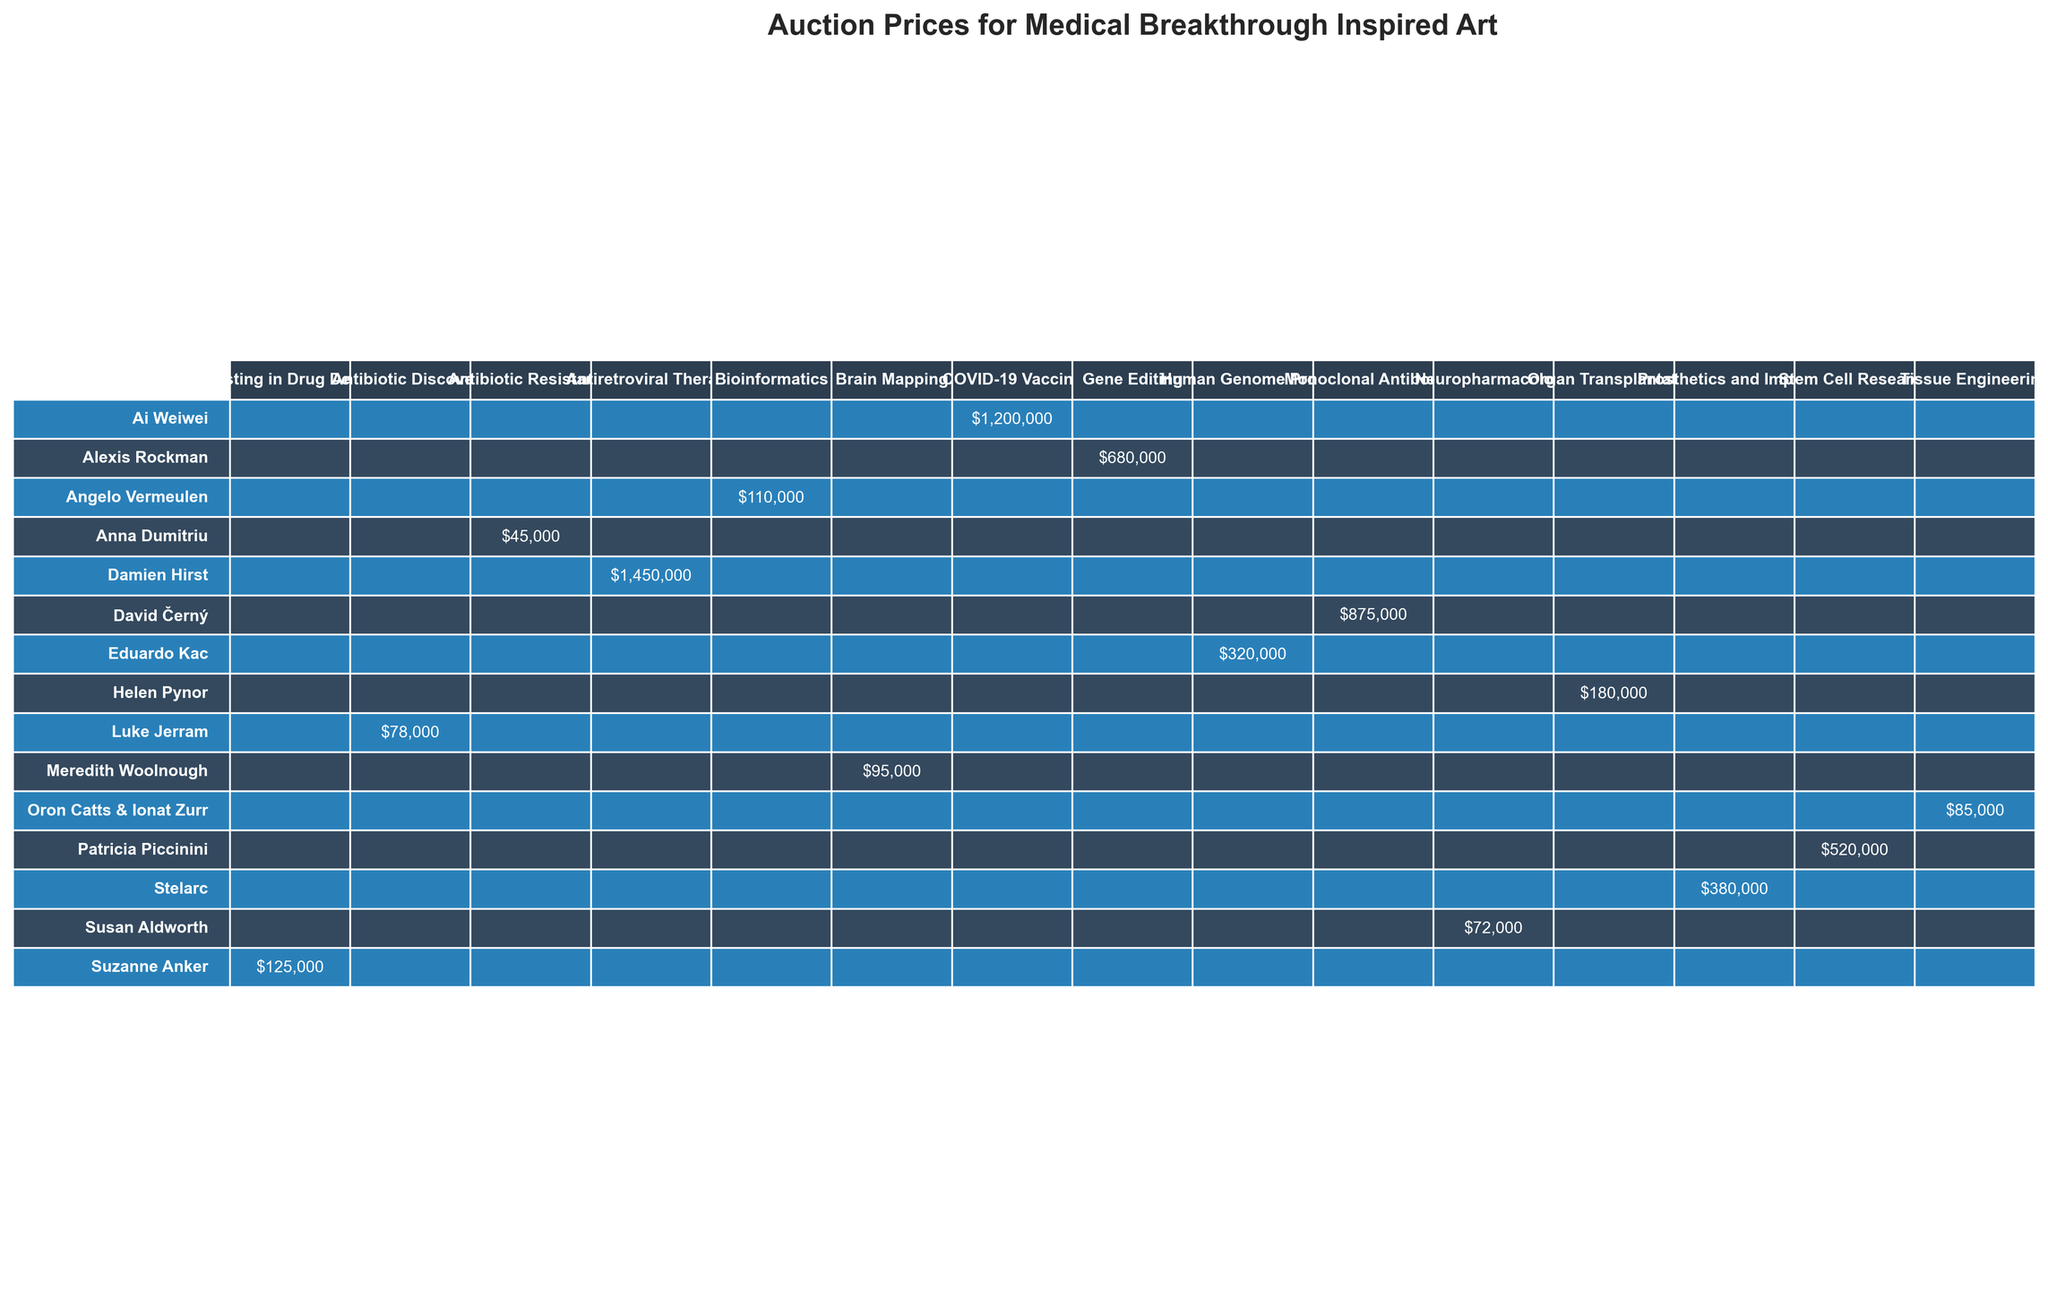What is the highest auction price for an artwork inspired by medical breakthroughs? The table shows that the highest auction price is for "The Cure - Orange" by Damien Hirst, which sold for $1,450,000 at Sotheby's in 2019.
Answer: $1,450,000 Which artwork had the lowest hammer price and what was its price? The lowest hammer price in the table is for "MRSA Quilt" by Anna Dumitriu, which sold for $45,000 through Phillips in 2020.
Answer: $45,000 How many artworks were sold at Christie’s? The table lists three artworks sold at Christie’s: "Antibodies," "The Body is a Big Place," and "Passing Thoughts."
Answer: 3 What is the total hammer price of all artworks sold at Sotheby's? The hammer prices for artworks sold at Sotheby's are $1,450,000 (Damien Hirst), $1,200,000 (Ai Weiwei), and $380,000 (Stelarc). Summing these gives $1,450,000 + $1,200,000 + $380,000 = $3,030,000.
Answer: $3,030,000 Which artist created a piece inspired by Gene Editing, and what was its hammer price? The artwork "CRISPR Landscape" by Alexis Rockman is inspired by Gene Editing and had a hammer price of $680,000.
Answer: Alexis Rockman, $680,000 Is there an artwork that uses living tissue as a medium? Yes, "Victimless Leather" by Oron Catts & Ionat Zurr is a living tissue installation, which can be confirmed in the table.
Answer: Yes What was the average auction price of artworks sold at Phillips? The auction prices at Phillips are $680,000 (Alexis Rockman), $78,000 (Luke Jerram), and $110,000 (Angelo Vermeulen), summing these gives $680,000 + $78,000 + $110,000 = $868,000. There are 3 artworks, so the average is $868,000 / 3 = $289,333.33.
Answer: $289,333 Who are the two artists that have works inspired by different aspects of antibiotic research? "E. coli" by Luke Jerram is inspired by Antibiotic Discovery and "MRSA Quilt" by Anna Dumitriu is based on Antibiotic Resistance; both can be found in the table.
Answer: Luke Jerram, Anna Dumitriu Which auction house had the most expensive artwork and what was its inspiration? Sotheby's had the most expensive artwork, "The Cure - Orange" by Damien Hirst, which was inspired by Antiretroviral Therapy and sold for $1,450,000.
Answer: Sotheby's, Antiretroviral Therapy Is there a piece that features multiple dimensions listed as "Variable"? Yes, both "Genesis" by Eduardo Kac and "The Body is a Big Place" by Helen Pynor have dimensions listed as "Variable" in the table.
Answer: Yes 